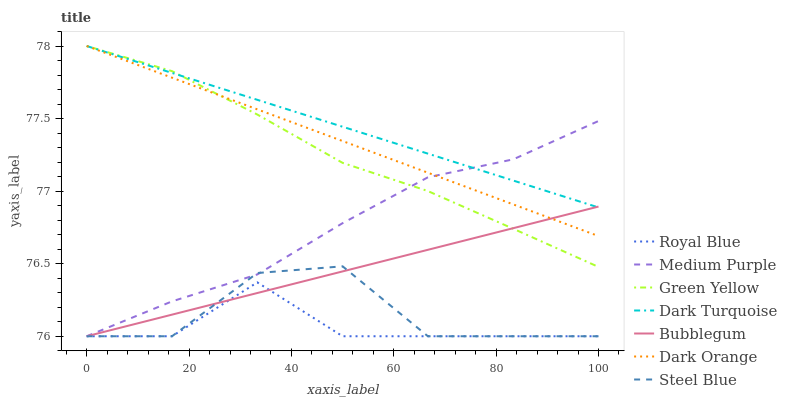Does Royal Blue have the minimum area under the curve?
Answer yes or no. Yes. Does Dark Turquoise have the maximum area under the curve?
Answer yes or no. Yes. Does Steel Blue have the minimum area under the curve?
Answer yes or no. No. Does Steel Blue have the maximum area under the curve?
Answer yes or no. No. Is Dark Orange the smoothest?
Answer yes or no. Yes. Is Steel Blue the roughest?
Answer yes or no. Yes. Is Dark Turquoise the smoothest?
Answer yes or no. No. Is Dark Turquoise the roughest?
Answer yes or no. No. Does Dark Turquoise have the lowest value?
Answer yes or no. No. Does Green Yellow have the highest value?
Answer yes or no. Yes. Does Steel Blue have the highest value?
Answer yes or no. No. Is Royal Blue less than Green Yellow?
Answer yes or no. Yes. Is Dark Turquoise greater than Steel Blue?
Answer yes or no. Yes. Does Medium Purple intersect Green Yellow?
Answer yes or no. Yes. Is Medium Purple less than Green Yellow?
Answer yes or no. No. Is Medium Purple greater than Green Yellow?
Answer yes or no. No. Does Royal Blue intersect Green Yellow?
Answer yes or no. No. 